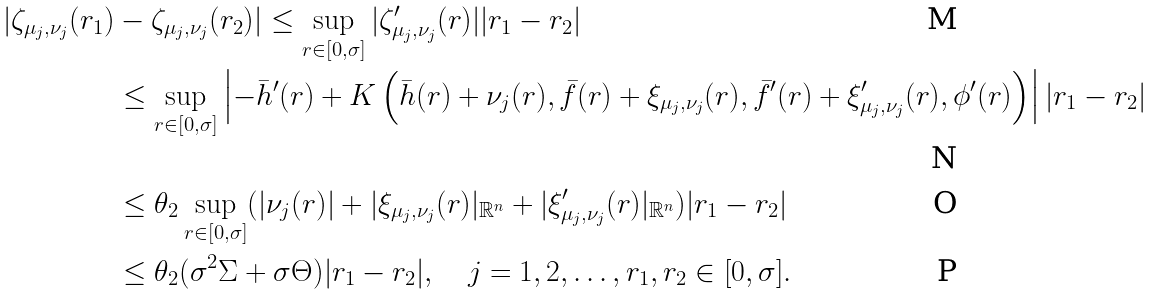<formula> <loc_0><loc_0><loc_500><loc_500>| \zeta _ { \mu _ { j } , \nu _ { j } } ( r _ { 1 } ) & - \zeta _ { \mu _ { j } , \nu _ { j } } ( r _ { 2 } ) | \leq \sup _ { r \in [ 0 , \sigma ] } | \zeta _ { \mu _ { j } , \nu _ { j } } ^ { \prime } ( r ) | | r _ { 1 } - r _ { 2 } | \\ & \leq \sup _ { r \in [ 0 , \sigma ] } \left | - \bar { h } ^ { \prime } ( r ) + K \left ( \bar { h } ( r ) + \nu _ { j } ( r ) , \bar { f } ( r ) + \xi _ { \mu _ { j } , \nu _ { j } } ( r ) , \bar { f } ^ { \prime } ( r ) + \xi _ { \mu _ { j } , \nu _ { j } } ^ { \prime } ( r ) , \phi ^ { \prime } ( r ) \right ) \right | | r _ { 1 } - r _ { 2 } | \\ & \leq \theta _ { 2 } \sup _ { r \in [ 0 , \sigma ] } ( | \nu _ { j } ( r ) | + | \xi _ { \mu _ { j } , \nu _ { j } } ( r ) | _ { \mathbb { R } ^ { n } } + | \xi _ { \mu _ { j } , \nu _ { j } } ^ { \prime } ( r ) | _ { \mathbb { R } ^ { n } } ) | r _ { 1 } - r _ { 2 } | \\ & \leq \theta _ { 2 } ( \sigma ^ { 2 } \Sigma + \sigma \Theta ) | r _ { 1 } - r _ { 2 } | , \quad j = 1 , 2 , \dots , r _ { 1 } , r _ { 2 } \in [ 0 , \sigma ] .</formula> 